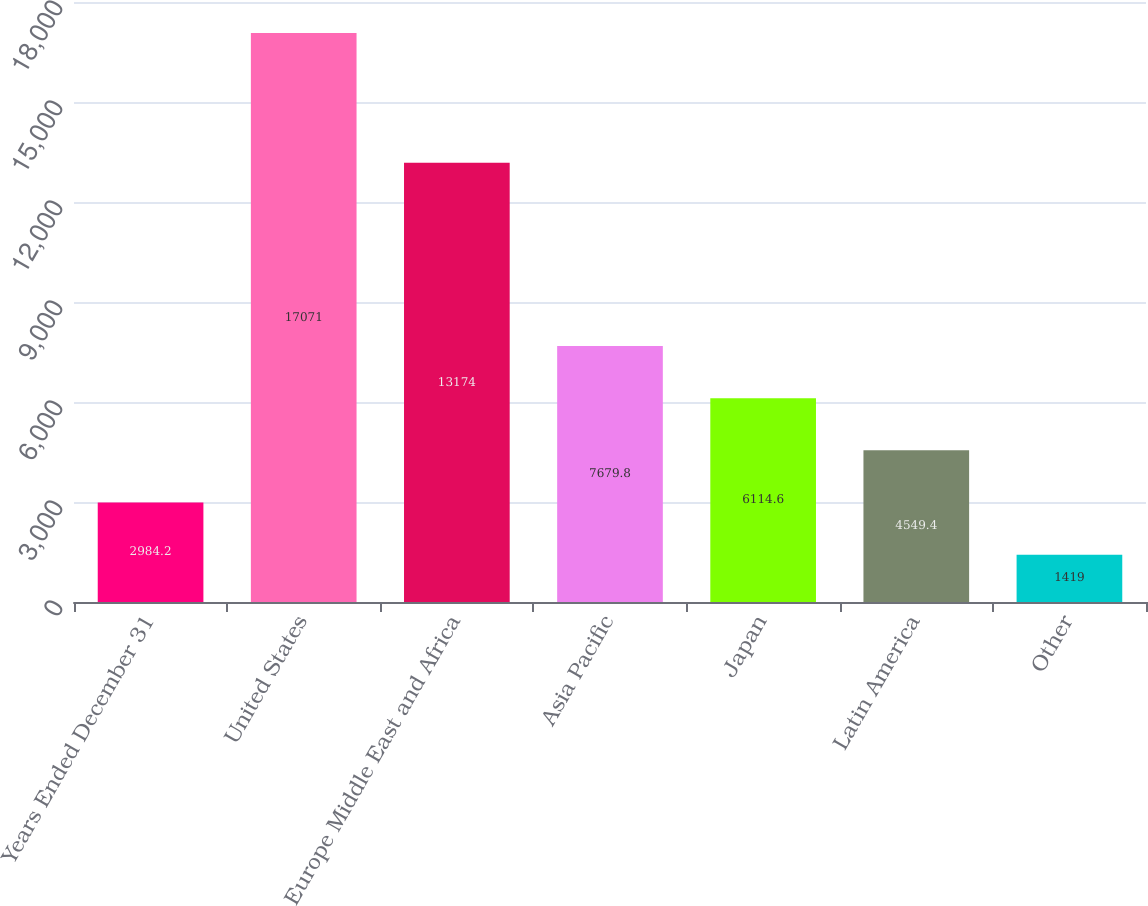Convert chart to OTSL. <chart><loc_0><loc_0><loc_500><loc_500><bar_chart><fcel>Years Ended December 31<fcel>United States<fcel>Europe Middle East and Africa<fcel>Asia Pacific<fcel>Japan<fcel>Latin America<fcel>Other<nl><fcel>2984.2<fcel>17071<fcel>13174<fcel>7679.8<fcel>6114.6<fcel>4549.4<fcel>1419<nl></chart> 